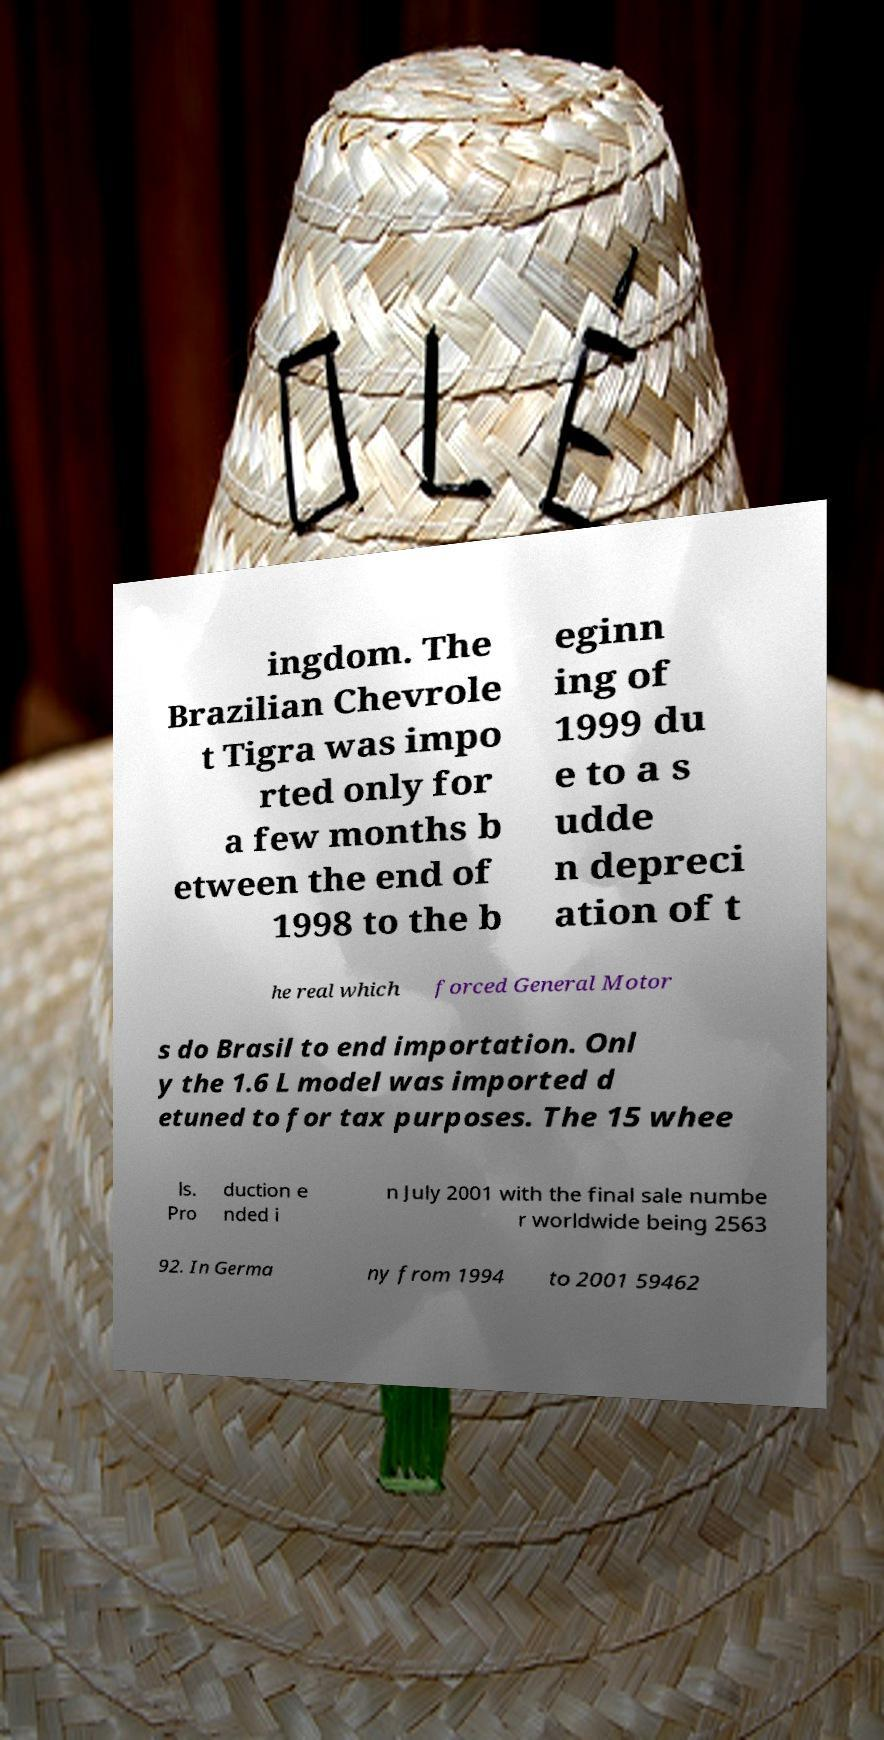Can you accurately transcribe the text from the provided image for me? ingdom. The Brazilian Chevrole t Tigra was impo rted only for a few months b etween the end of 1998 to the b eginn ing of 1999 du e to a s udde n depreci ation of t he real which forced General Motor s do Brasil to end importation. Onl y the 1.6 L model was imported d etuned to for tax purposes. The 15 whee ls. Pro duction e nded i n July 2001 with the final sale numbe r worldwide being 2563 92. In Germa ny from 1994 to 2001 59462 